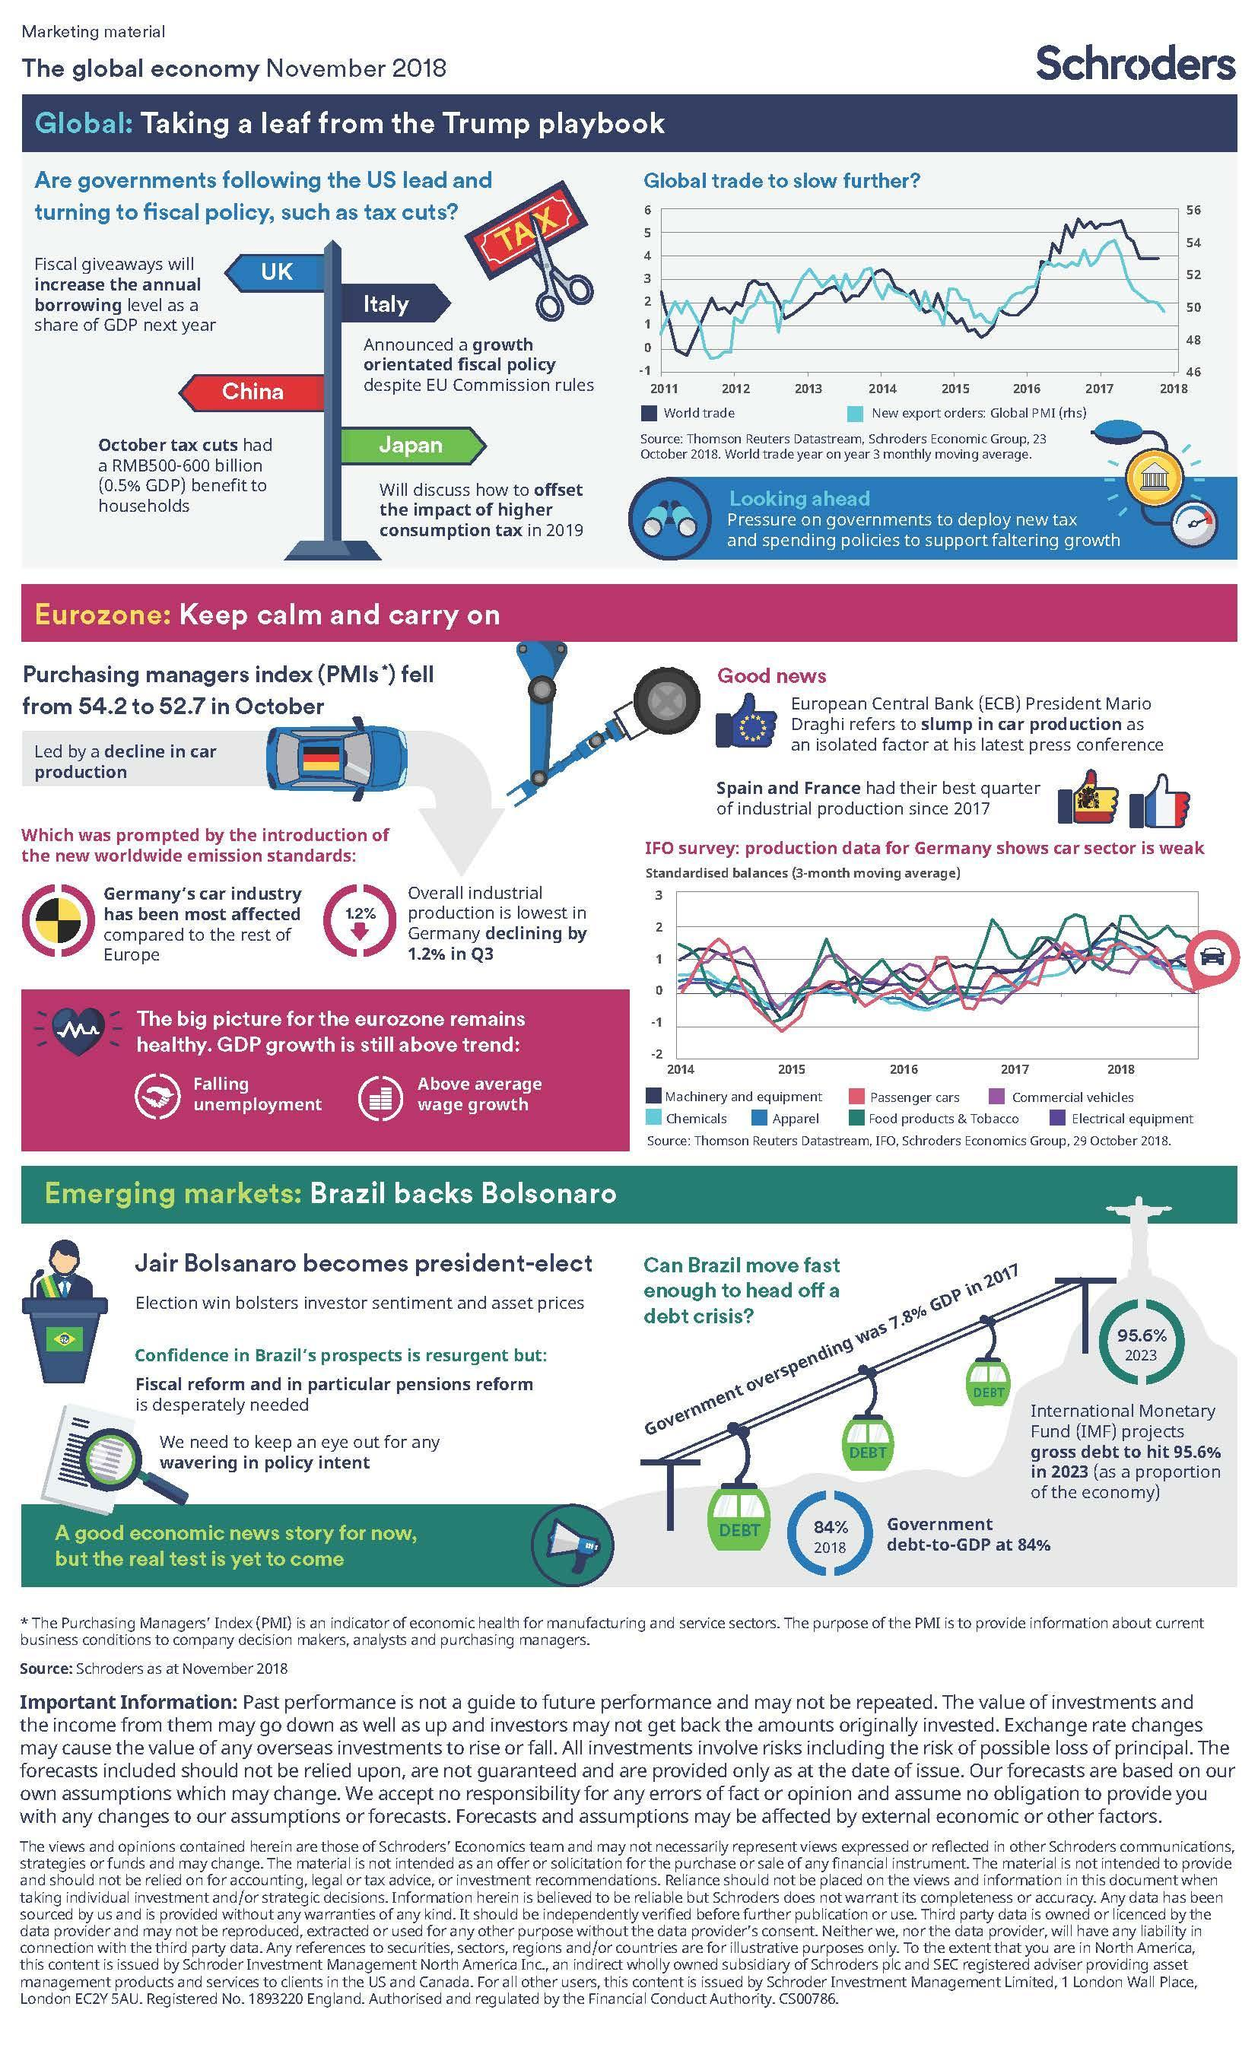Which color represents the Apparel industry in the graph, blue, pink, or green?
Answer the question with a short phrase. blue How many other countries are following the US lead and turning to fiscal policy such as tax cuts? 4 Which production sector along with passenger cars shows the weakest growth in 2018? Commercial vehicles Which production industry shows the highest growth in the 2018? Food products & Tobacco 